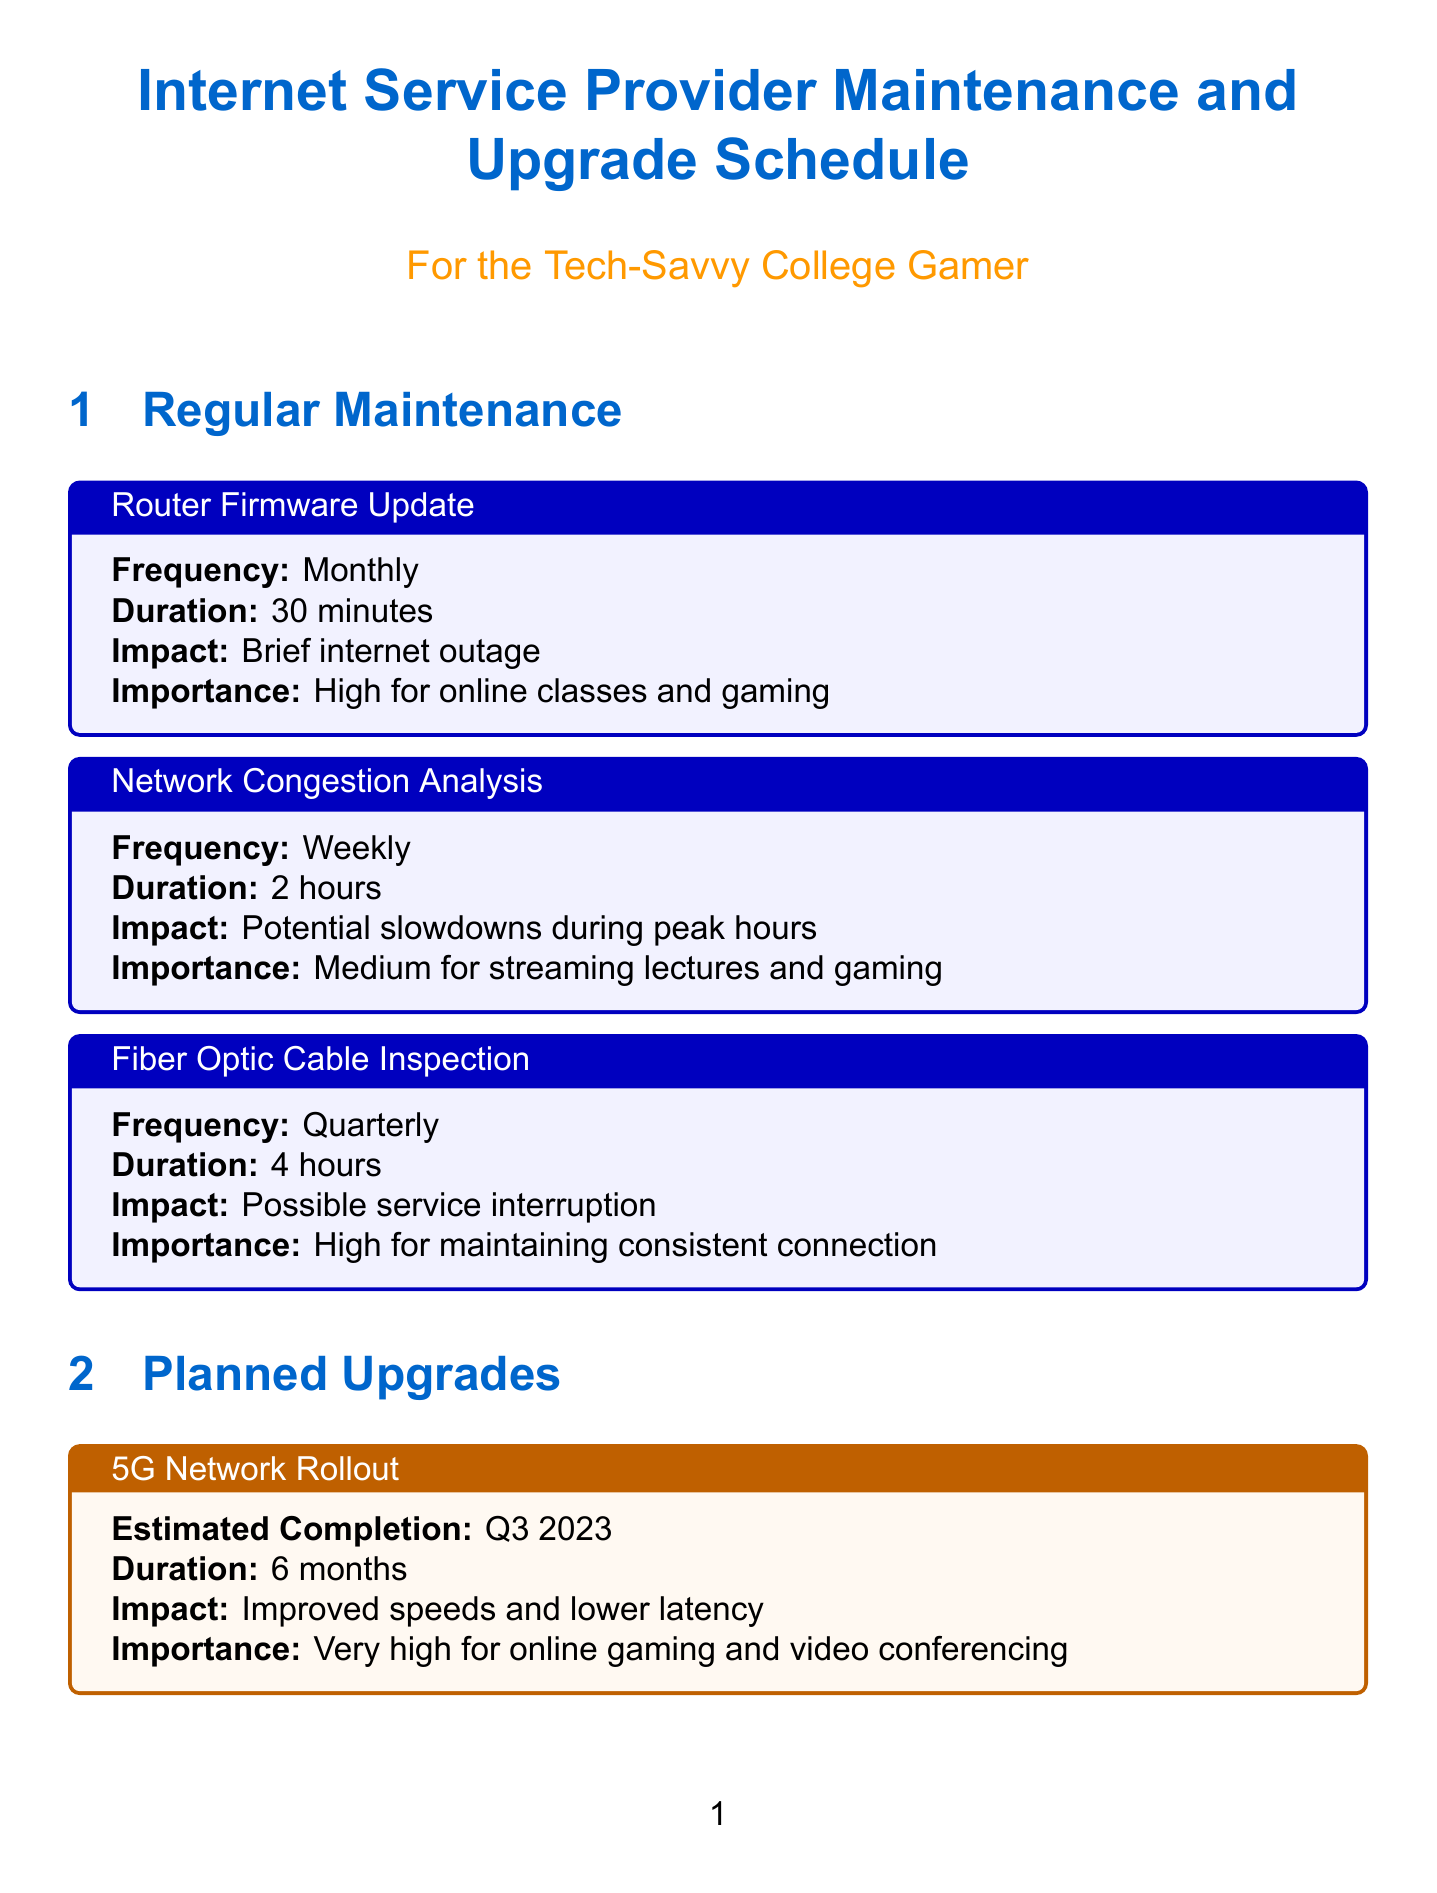What is the frequency of router firmware updates? The frequency of router firmware updates is stated as "Monthly" in the document.
Answer: Monthly How long does network congestion analysis take? The duration for network congestion analysis is given as "2 hours" in the document.
Answer: 2 hours What is the estimated completion date for the 5G network rollout? The estimated completion for the 5G network rollout is indicated as "Q3 2023."
Answer: Q3 2023 What importance level is assigned to the Finals week bandwidth boost? The importance level of the Finals week bandwidth boost is described as "Very high" for online exams and project submissions.
Answer: Very high When do gaming server prioritization measures take effect? The document specifies that gaming server prioritization takes place on "Weekends and evenings."
Answer: Weekends and evenings How many months is the duration for fiber-to-the-home expansion? The duration for the fiber-to-the-home expansion is stated as "8 months."
Answer: 8 months What is the impact of IPv6 implementation? The document notes that the impact of IPv6 implementation is "Better network performance and security."
Answer: Better network performance and security What is the duration of the finals week bandwidth boost? The document lists the duration of the finals week bandwidth boost as "2 weeks."
Answer: 2 weeks What is the frequency of customer satisfaction surveys? The frequency of customer satisfaction surveys is mentioned as "Quarterly."
Answer: Quarterly 